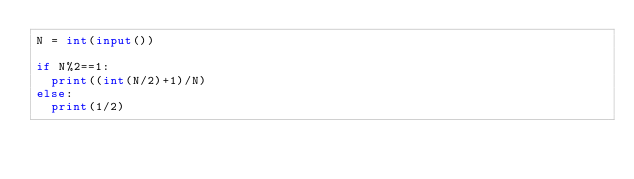Convert code to text. <code><loc_0><loc_0><loc_500><loc_500><_Python_>N = int(input())

if N%2==1:
  print((int(N/2)+1)/N)
else:
  print(1/2)</code> 